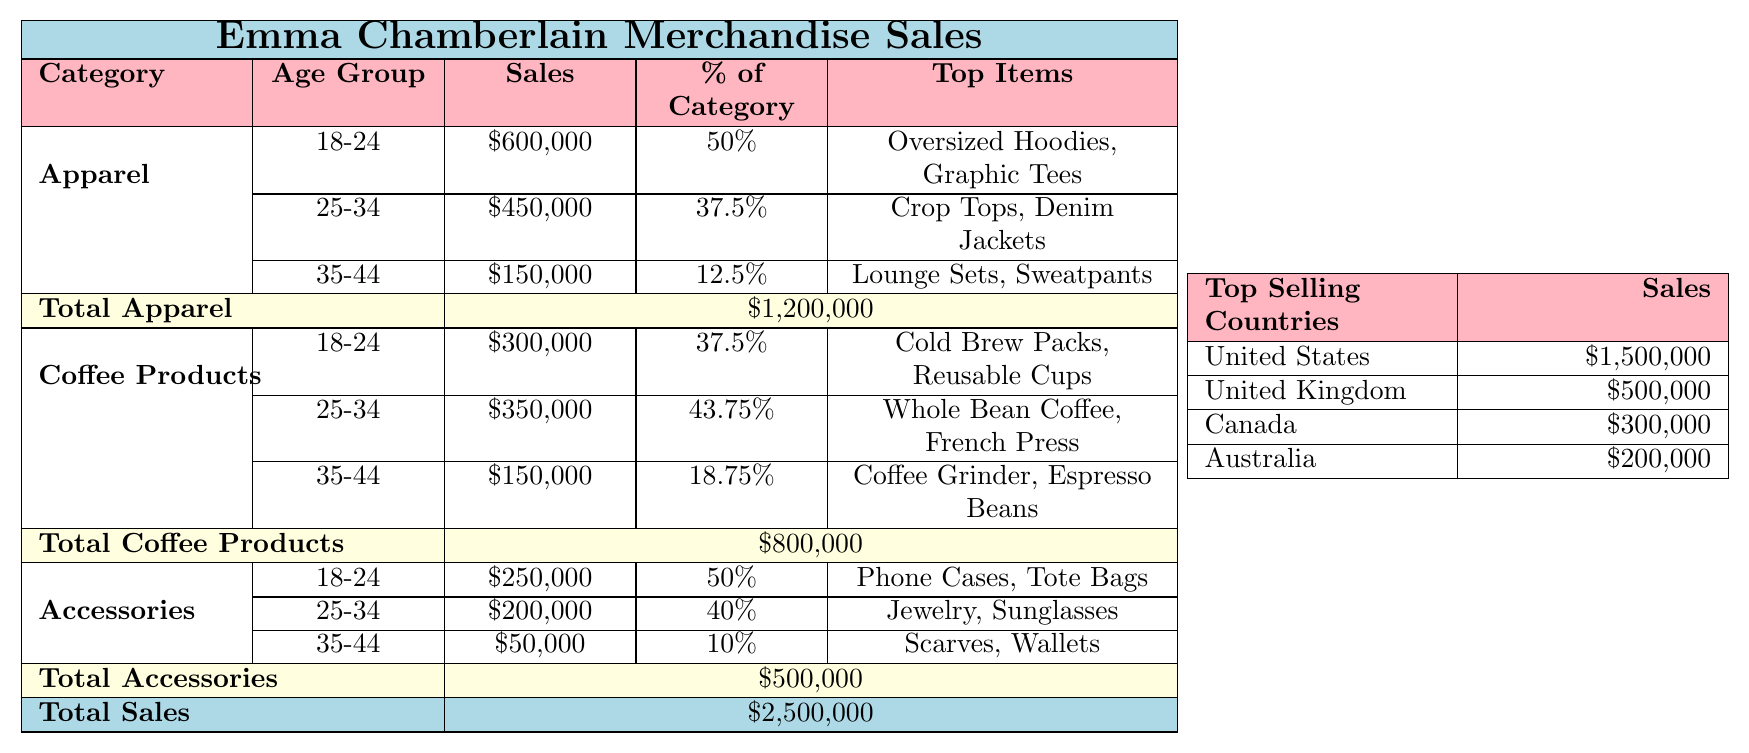What is the total sales for the Apparel category? The total sales for the Apparel category is clearly stated in the table as $1,200,000.
Answer: $1,200,000 Which age group spent the most on Coffee Products? The age group 25-34 has sales of $350,000, which is higher than the other age groups (18-24: $300,000 and 35-44: $150,000).
Answer: 25-34 What is the percentage of total sales from Accessories compared to the total sales? The total sales for Accessories is $500,000. To find the percentage, divide $500,000 by $2,500,000 and multiply by 100. The calculation is ($500,000 / $2,500,000) * 100 = 20%.
Answer: 20% Are the sales figures for the United Kingdom higher than those for Canada? Yes, the sales for the United Kingdom are $500,000, which is greater than Canada's sales of $300,000.
Answer: Yes What are the top items sold in the 35-44 age group for Apparel? The table lists Lounge Sets and Sweatpants as the top items for the 35-44 age group under Apparel.
Answer: Lounge Sets and Sweatpants What is the total sales across all age groups in the Accessories category? The total sales for Accessories are given as $500,000, calculated by summing the sales from all age groups—$250,000 (18-24) + $200,000 (25-34) + $50,000 (35-44) equals $500,000.
Answer: $500,000 Which product category has the highest sales from the 18-24 age group? Apparel has the highest sales of $600,000 from the 18-24 age group, compared to Coffee Products' $300,000 and Accessories' $250,000.
Answer: Apparel What is the total sales from the top-selling country, the United States? The sales for the United States are explicitly stated as $1,500,000 in the table.
Answer: $1,500,000 What is the average sales amount for the 25-34 age group across all categories? The sales amounts are $450,000 (Apparel), $350,000 (Coffee Products), and $200,000 (Accessories). Totaling these gives $1,000,000, and dividing by 3 (the number of categories) provides an average of $333,333.33.
Answer: $333,333.33 Which category contributed the least to total sales? Accessories have the least total sales of $500,000, while Apparel is $1,200,000 and Coffee Products are $800,000.
Answer: Accessories 